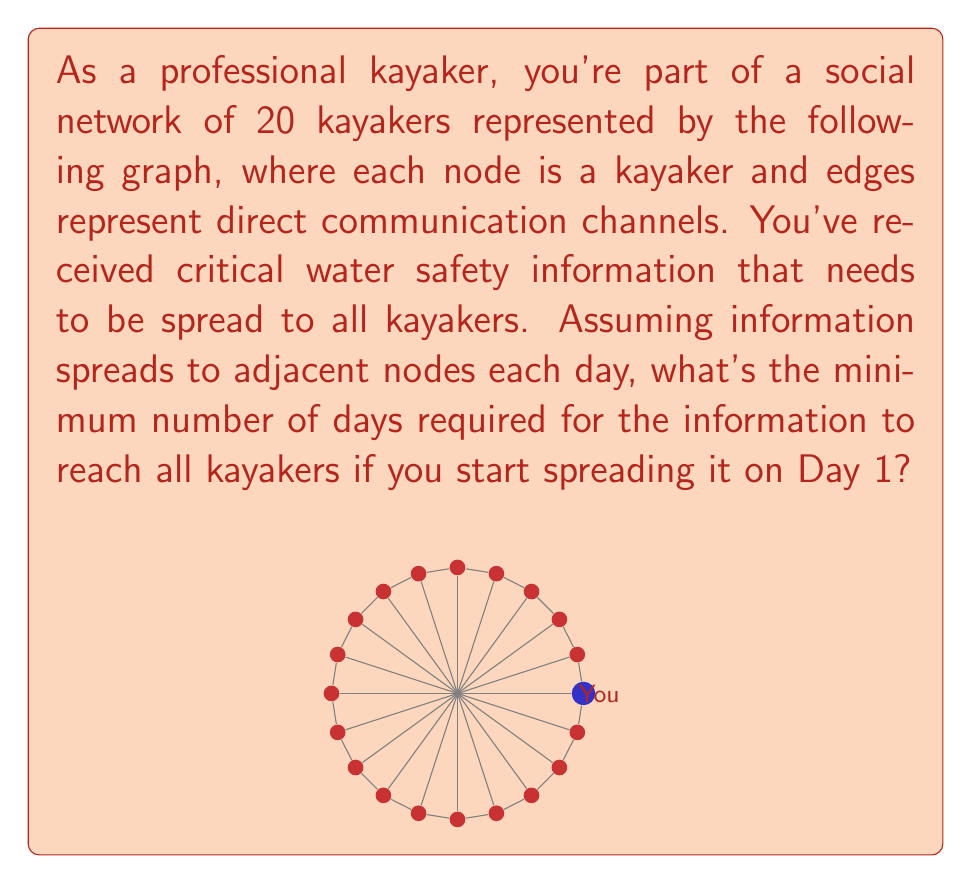Could you help me with this problem? To solve this problem, we need to analyze the structure of the given graph and determine the maximum distance from the starting node (you) to any other node. This is equivalent to finding the graph's radius with you as the center.

Step 1: Identify the graph structure
The graph is a circulant graph with 20 nodes, where each node is connected to its two adjacent nodes and the node directly across from it.

Step 2: Analyze the spreading pattern
- Day 1: You have the information
- Day 2: Information spreads to your 3 direct connections (2 adjacent, 1 across)
- Day 3: Information reaches 6 more kayakers (2 from each of the 3 reached on Day 2)
- Day 4: Information reaches 6 more kayakers
- Day 5: Information reaches the last 4 kayakers

Step 3: Calculate the minimum number of days
The information needs 4 steps to reach the farthest kayakers, which are those 4 nodes reached on Day 5.

Therefore, the minimum number of days required for the information to reach all kayakers is 5 (including the first day when you receive the information).

This result can be verified by observing that the graph has a diameter of 5, which means the maximum distance between any two nodes is 5 edges.
Answer: 5 days 